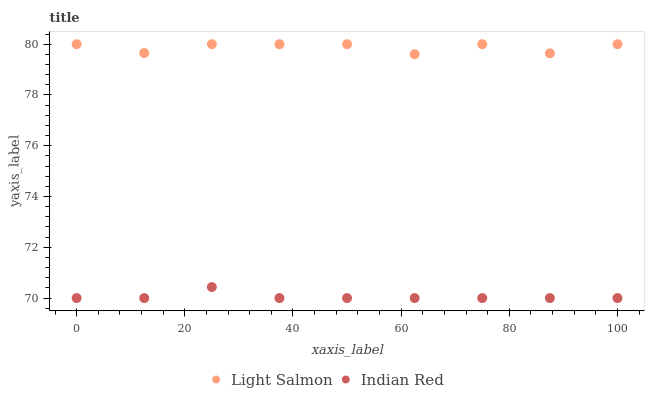Does Indian Red have the minimum area under the curve?
Answer yes or no. Yes. Does Light Salmon have the maximum area under the curve?
Answer yes or no. Yes. Does Indian Red have the maximum area under the curve?
Answer yes or no. No. Is Indian Red the smoothest?
Answer yes or no. Yes. Is Light Salmon the roughest?
Answer yes or no. Yes. Is Indian Red the roughest?
Answer yes or no. No. Does Indian Red have the lowest value?
Answer yes or no. Yes. Does Light Salmon have the highest value?
Answer yes or no. Yes. Does Indian Red have the highest value?
Answer yes or no. No. Is Indian Red less than Light Salmon?
Answer yes or no. Yes. Is Light Salmon greater than Indian Red?
Answer yes or no. Yes. Does Indian Red intersect Light Salmon?
Answer yes or no. No. 